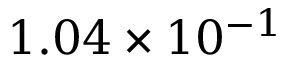<formula> <loc_0><loc_0><loc_500><loc_500>1 . 0 4 \times 1 0 ^ { - 1 }</formula> 